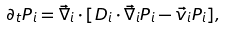Convert formula to latex. <formula><loc_0><loc_0><loc_500><loc_500>\partial _ { t } P _ { i } = \vec { \nabla } _ { i } \cdot [ D _ { i } \cdot \vec { \nabla } _ { i } P _ { i } - \vec { v } _ { i } P _ { i } ] ,</formula> 